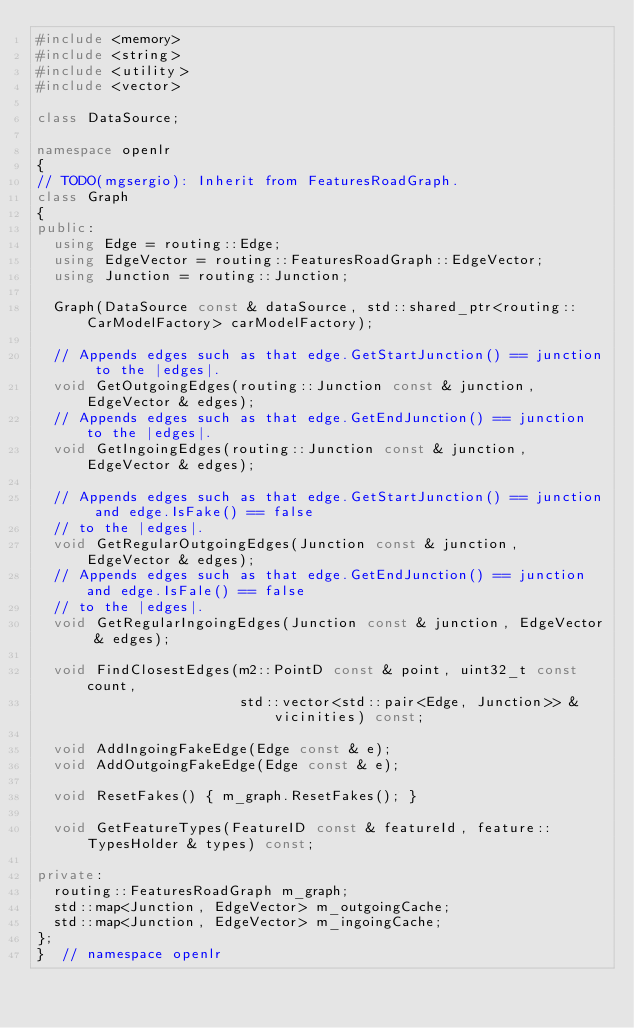Convert code to text. <code><loc_0><loc_0><loc_500><loc_500><_C++_>#include <memory>
#include <string>
#include <utility>
#include <vector>

class DataSource;

namespace openlr
{
// TODO(mgsergio): Inherit from FeaturesRoadGraph.
class Graph
{
public:
  using Edge = routing::Edge;
  using EdgeVector = routing::FeaturesRoadGraph::EdgeVector;
  using Junction = routing::Junction;

  Graph(DataSource const & dataSource, std::shared_ptr<routing::CarModelFactory> carModelFactory);

  // Appends edges such as that edge.GetStartJunction() == junction to the |edges|.
  void GetOutgoingEdges(routing::Junction const & junction, EdgeVector & edges);
  // Appends edges such as that edge.GetEndJunction() == junction to the |edges|.
  void GetIngoingEdges(routing::Junction const & junction, EdgeVector & edges);

  // Appends edges such as that edge.GetStartJunction() == junction and edge.IsFake() == false
  // to the |edges|.
  void GetRegularOutgoingEdges(Junction const & junction, EdgeVector & edges);
  // Appends edges such as that edge.GetEndJunction() == junction and edge.IsFale() == false
  // to the |edges|.
  void GetRegularIngoingEdges(Junction const & junction, EdgeVector & edges);

  void FindClosestEdges(m2::PointD const & point, uint32_t const count,
                        std::vector<std::pair<Edge, Junction>> & vicinities) const;

  void AddIngoingFakeEdge(Edge const & e);
  void AddOutgoingFakeEdge(Edge const & e);

  void ResetFakes() { m_graph.ResetFakes(); }

  void GetFeatureTypes(FeatureID const & featureId, feature::TypesHolder & types) const;

private:
  routing::FeaturesRoadGraph m_graph;
  std::map<Junction, EdgeVector> m_outgoingCache;
  std::map<Junction, EdgeVector> m_ingoingCache;
};
}  // namespace openlr
</code> 